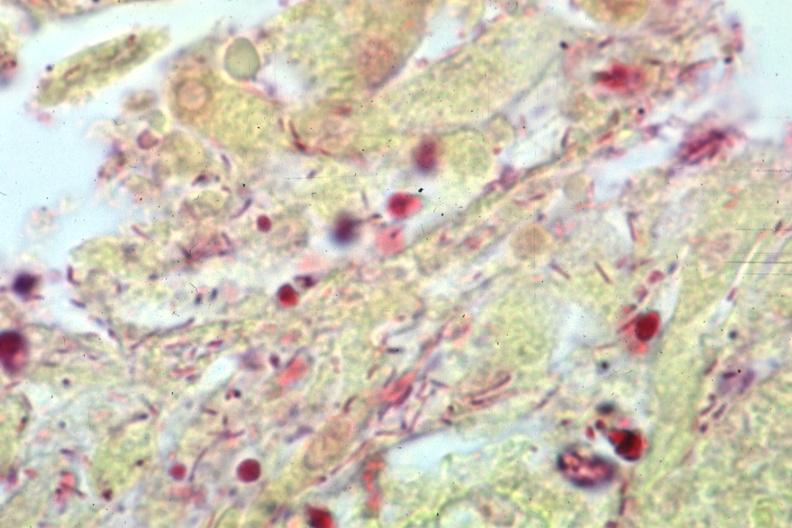what is present?
Answer the question using a single word or phrase. Meningitis purulent 